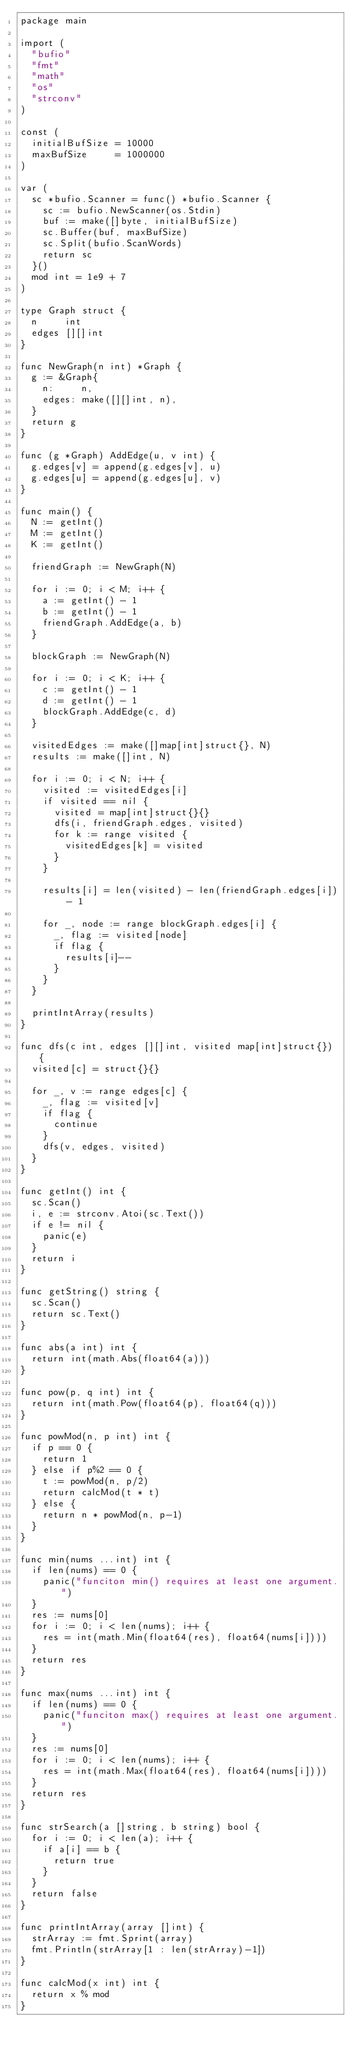Convert code to text. <code><loc_0><loc_0><loc_500><loc_500><_Go_>package main

import (
	"bufio"
	"fmt"
	"math"
	"os"
	"strconv"
)

const (
	initialBufSize = 10000
	maxBufSize     = 1000000
)

var (
	sc *bufio.Scanner = func() *bufio.Scanner {
		sc := bufio.NewScanner(os.Stdin)
		buf := make([]byte, initialBufSize)
		sc.Buffer(buf, maxBufSize)
		sc.Split(bufio.ScanWords)
		return sc
	}()
	mod int = 1e9 + 7
)

type Graph struct {
	n     int
	edges [][]int
}

func NewGraph(n int) *Graph {
	g := &Graph{
		n:     n,
		edges: make([][]int, n),
	}
	return g
}

func (g *Graph) AddEdge(u, v int) {
	g.edges[v] = append(g.edges[v], u)
	g.edges[u] = append(g.edges[u], v)
}

func main() {
	N := getInt()
	M := getInt()
	K := getInt()

	friendGraph := NewGraph(N)

	for i := 0; i < M; i++ {
		a := getInt() - 1
		b := getInt() - 1
		friendGraph.AddEdge(a, b)
	}

	blockGraph := NewGraph(N)

	for i := 0; i < K; i++ {
		c := getInt() - 1
		d := getInt() - 1
		blockGraph.AddEdge(c, d)
	}

	visitedEdges := make([]map[int]struct{}, N)
	results := make([]int, N)

	for i := 0; i < N; i++ {
		visited := visitedEdges[i]
		if visited == nil {
			visited = map[int]struct{}{}
			dfs(i, friendGraph.edges, visited)
			for k := range visited {
				visitedEdges[k] = visited
			}
		}

		results[i] = len(visited) - len(friendGraph.edges[i]) - 1

		for _, node := range blockGraph.edges[i] {
			_, flag := visited[node]
			if flag {
				results[i]--
			}
		}
	}

	printIntArray(results)
}

func dfs(c int, edges [][]int, visited map[int]struct{}) {
	visited[c] = struct{}{}

	for _, v := range edges[c] {
		_, flag := visited[v]
		if flag {
			continue
		}
		dfs(v, edges, visited)
	}
}

func getInt() int {
	sc.Scan()
	i, e := strconv.Atoi(sc.Text())
	if e != nil {
		panic(e)
	}
	return i
}

func getString() string {
	sc.Scan()
	return sc.Text()
}

func abs(a int) int {
	return int(math.Abs(float64(a)))
}

func pow(p, q int) int {
	return int(math.Pow(float64(p), float64(q)))
}

func powMod(n, p int) int {
	if p == 0 {
		return 1
	} else if p%2 == 0 {
		t := powMod(n, p/2)
		return calcMod(t * t)
	} else {
		return n * powMod(n, p-1)
	}
}

func min(nums ...int) int {
	if len(nums) == 0 {
		panic("funciton min() requires at least one argument.")
	}
	res := nums[0]
	for i := 0; i < len(nums); i++ {
		res = int(math.Min(float64(res), float64(nums[i])))
	}
	return res
}

func max(nums ...int) int {
	if len(nums) == 0 {
		panic("funciton max() requires at least one argument.")
	}
	res := nums[0]
	for i := 0; i < len(nums); i++ {
		res = int(math.Max(float64(res), float64(nums[i])))
	}
	return res
}

func strSearch(a []string, b string) bool {
	for i := 0; i < len(a); i++ {
		if a[i] == b {
			return true
		}
	}
	return false
}

func printIntArray(array []int) {
	strArray := fmt.Sprint(array)
	fmt.Println(strArray[1 : len(strArray)-1])
}

func calcMod(x int) int {
	return x % mod
}
</code> 